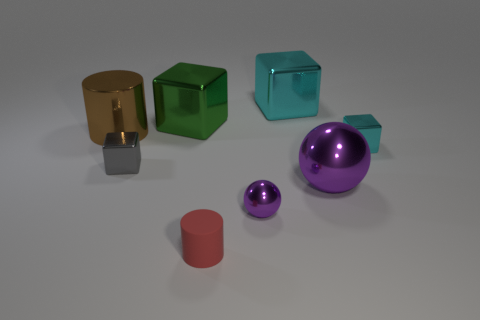Subtract all purple balls. How many were subtracted if there are1purple balls left? 1 Subtract all small cyan blocks. How many blocks are left? 3 Subtract all gray cubes. How many cubes are left? 3 Subtract all spheres. How many objects are left? 6 Subtract all red spheres. How many cyan blocks are left? 2 Add 3 yellow matte cylinders. How many yellow matte cylinders exist? 3 Add 1 red cubes. How many objects exist? 9 Subtract 0 yellow cylinders. How many objects are left? 8 Subtract 1 cylinders. How many cylinders are left? 1 Subtract all brown cylinders. Subtract all yellow blocks. How many cylinders are left? 1 